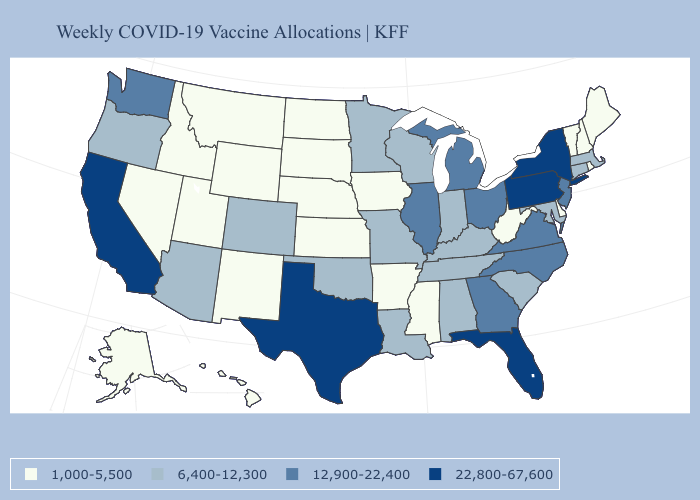Among the states that border Pennsylvania , which have the lowest value?
Answer briefly. Delaware, West Virginia. Which states hav the highest value in the Northeast?
Keep it brief. New York, Pennsylvania. Does Oklahoma have a higher value than Hawaii?
Keep it brief. Yes. Name the states that have a value in the range 6,400-12,300?
Answer briefly. Alabama, Arizona, Colorado, Connecticut, Indiana, Kentucky, Louisiana, Maryland, Massachusetts, Minnesota, Missouri, Oklahoma, Oregon, South Carolina, Tennessee, Wisconsin. Name the states that have a value in the range 12,900-22,400?
Quick response, please. Georgia, Illinois, Michigan, New Jersey, North Carolina, Ohio, Virginia, Washington. What is the lowest value in the South?
Answer briefly. 1,000-5,500. What is the value of Utah?
Quick response, please. 1,000-5,500. Which states have the highest value in the USA?
Be succinct. California, Florida, New York, Pennsylvania, Texas. What is the value of Louisiana?
Give a very brief answer. 6,400-12,300. What is the highest value in the MidWest ?
Short answer required. 12,900-22,400. Which states hav the highest value in the West?
Quick response, please. California. Among the states that border Connecticut , which have the highest value?
Quick response, please. New York. Name the states that have a value in the range 1,000-5,500?
Give a very brief answer. Alaska, Arkansas, Delaware, Hawaii, Idaho, Iowa, Kansas, Maine, Mississippi, Montana, Nebraska, Nevada, New Hampshire, New Mexico, North Dakota, Rhode Island, South Dakota, Utah, Vermont, West Virginia, Wyoming. Does South Carolina have the highest value in the USA?
Keep it brief. No. Which states have the highest value in the USA?
Write a very short answer. California, Florida, New York, Pennsylvania, Texas. 